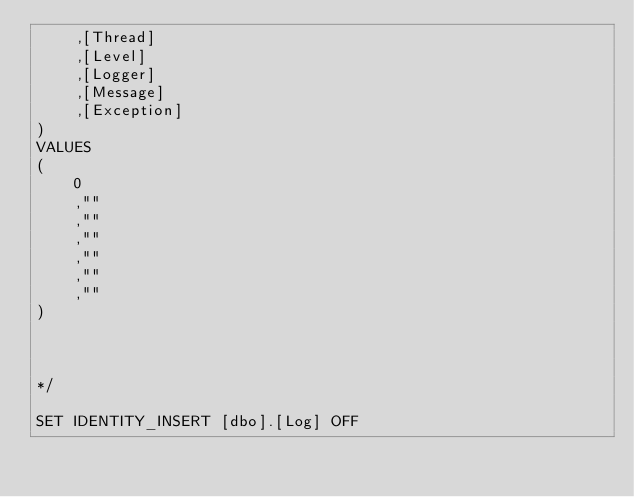<code> <loc_0><loc_0><loc_500><loc_500><_SQL_>		,[Thread]
		,[Level]
		,[Logger]
		,[Message]
		,[Exception]
)
VALUES
(
		0
		,""
		,""
		,""
		,""
		,""
		,""
)



*/

SET IDENTITY_INSERT [dbo].[Log] OFF

</code> 